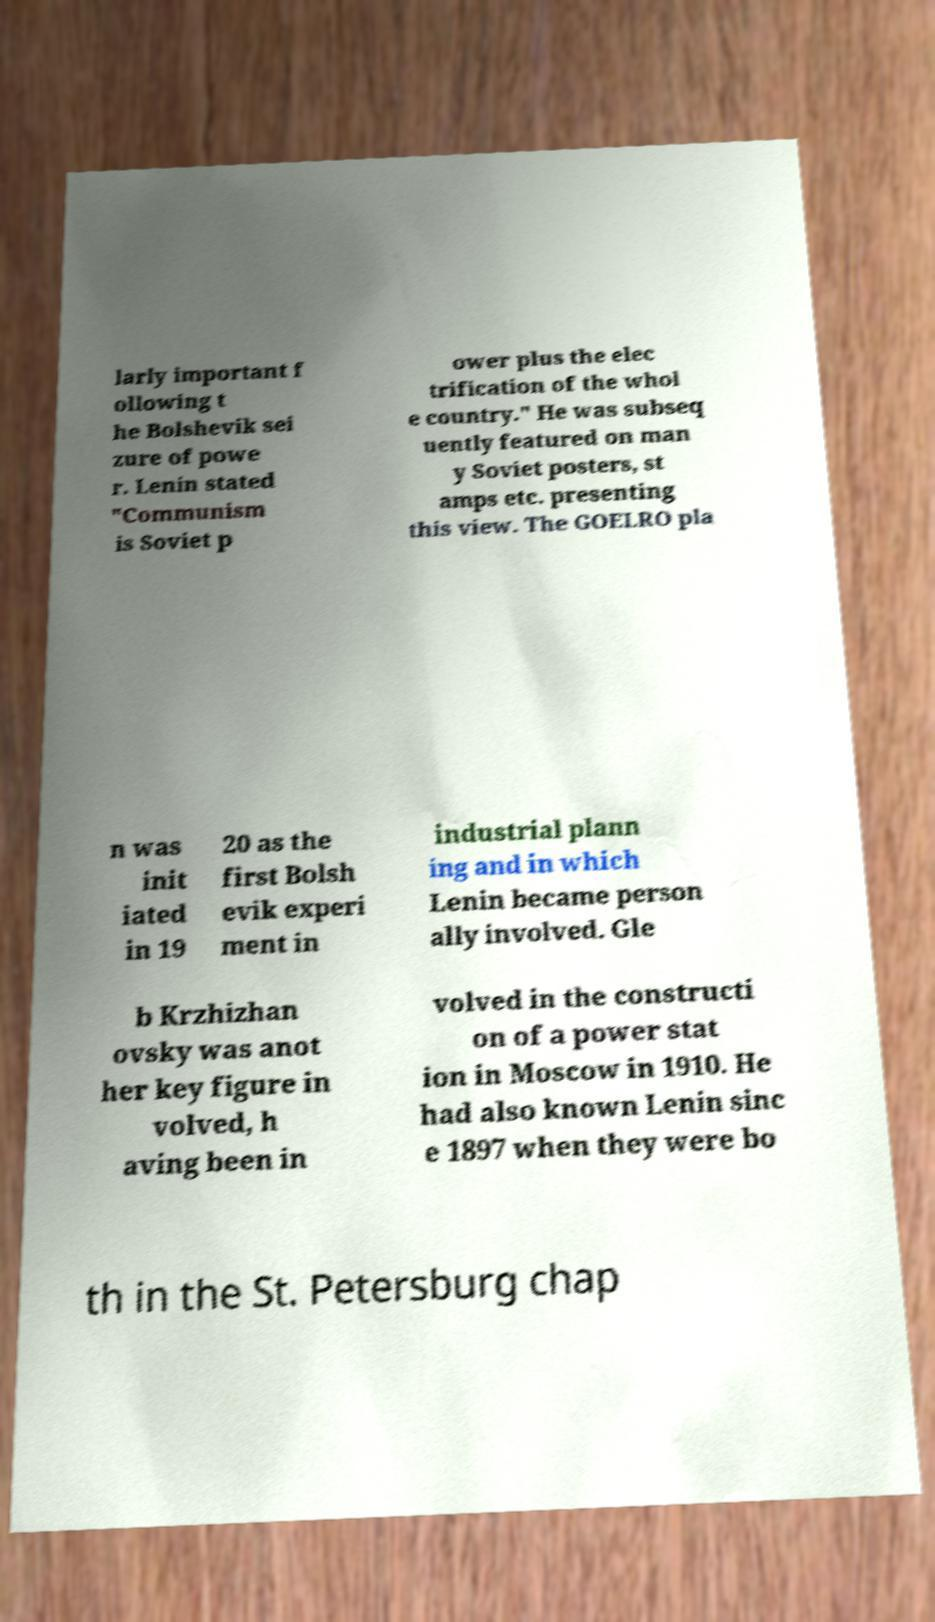Please identify and transcribe the text found in this image. larly important f ollowing t he Bolshevik sei zure of powe r. Lenin stated "Communism is Soviet p ower plus the elec trification of the whol e country." He was subseq uently featured on man y Soviet posters, st amps etc. presenting this view. The GOELRO pla n was init iated in 19 20 as the first Bolsh evik experi ment in industrial plann ing and in which Lenin became person ally involved. Gle b Krzhizhan ovsky was anot her key figure in volved, h aving been in volved in the constructi on of a power stat ion in Moscow in 1910. He had also known Lenin sinc e 1897 when they were bo th in the St. Petersburg chap 